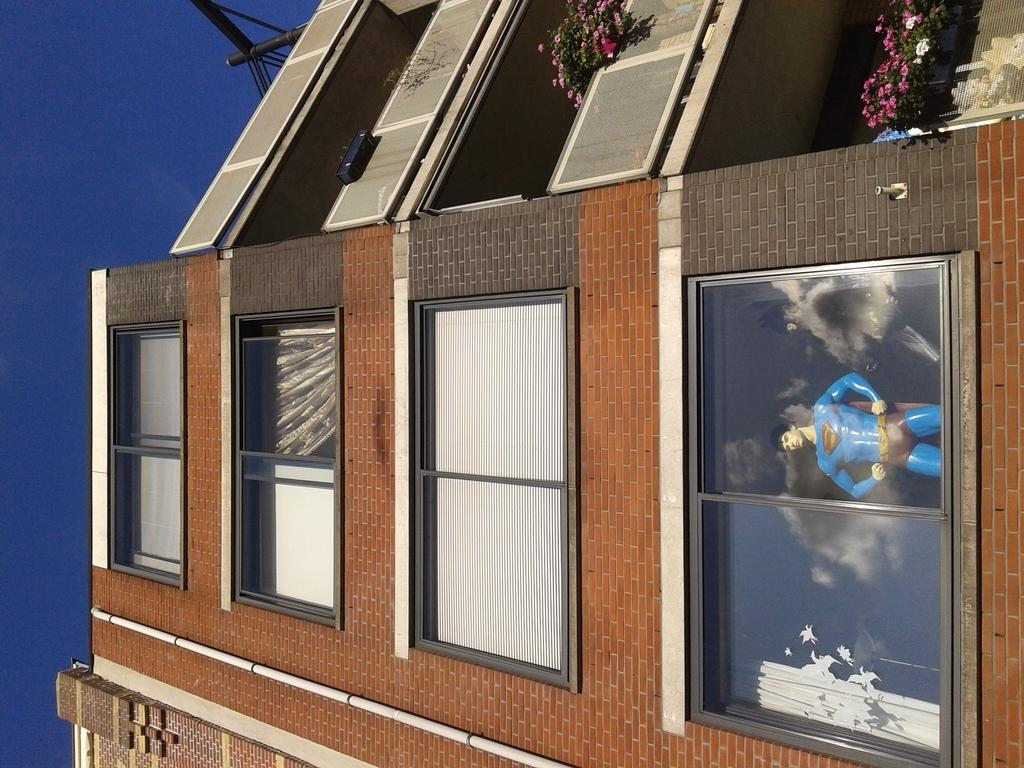What type of structure is visible in the image? There is a building in the image. What feature can be seen on the windows of the building? The windows have window blinds and curtains. Is there any indication of a specific theme or decoration inside the building? Yes, there is a Batman toy in the building. What type of vegetation is present in the image? There are flower plants in the image. How does the building express regret in the image? The building does not express regret in the image, as it is an inanimate object and cannot experience emotions. 